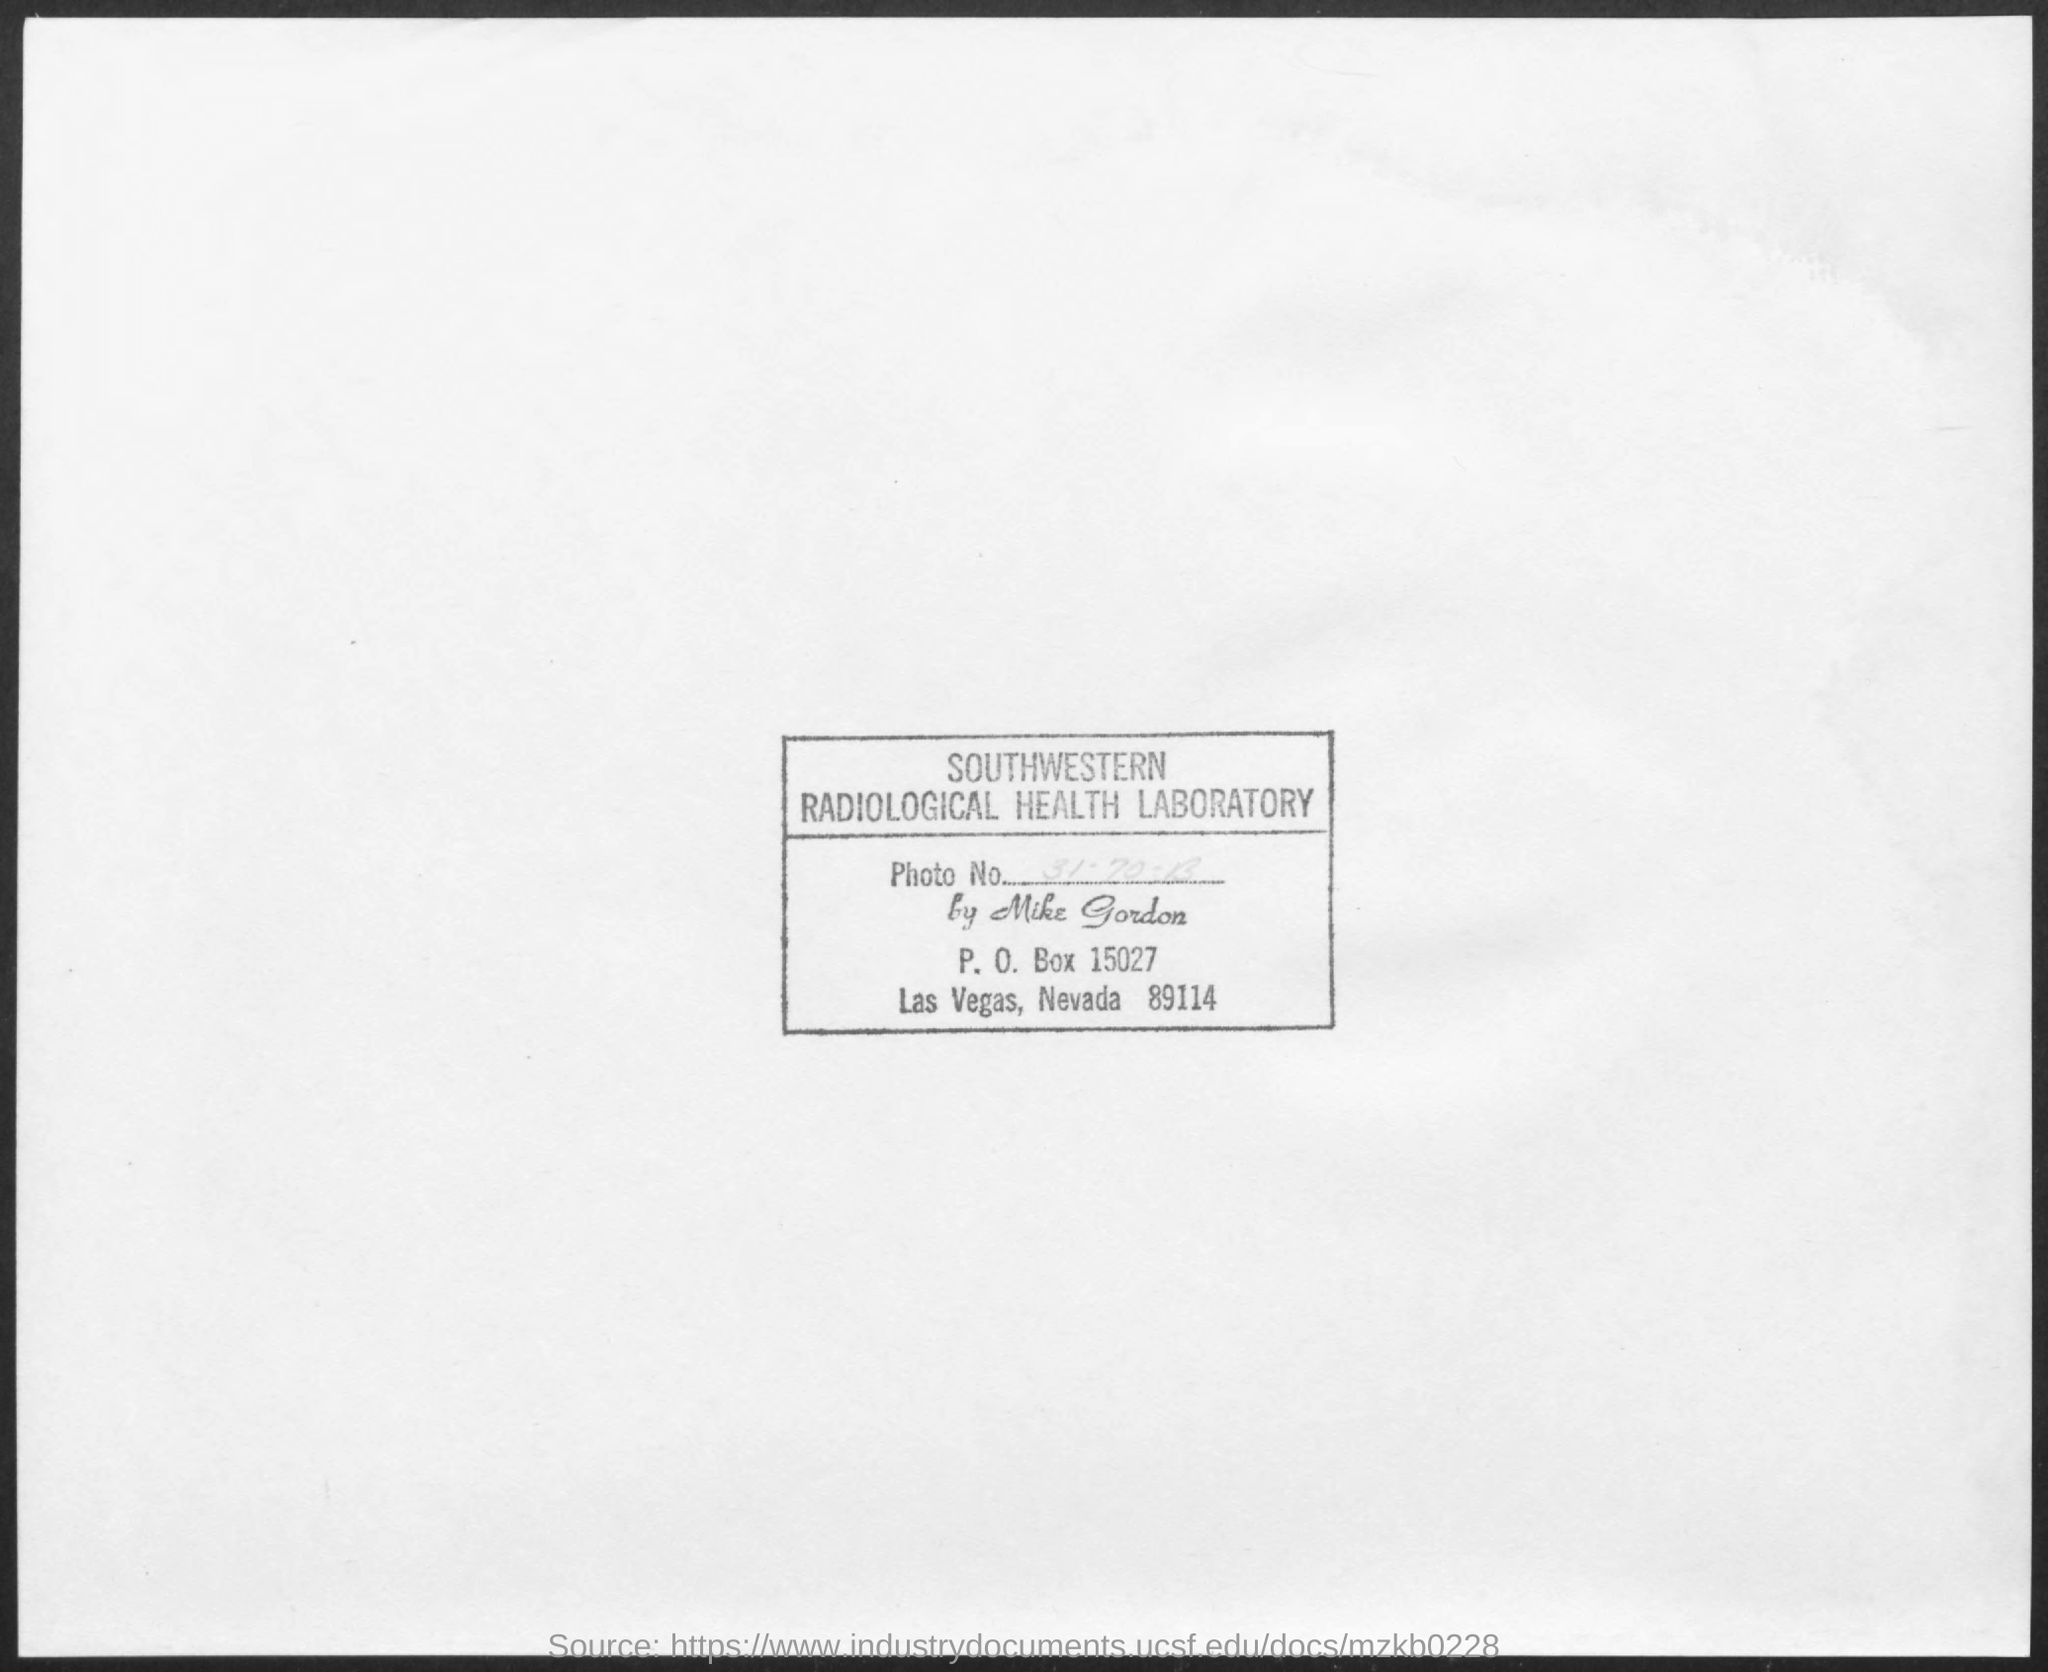Draw attention to some important aspects in this diagram. The P.O. Box is a physical address used for receiving mail and packages that is typically found at a post office or mail facility. Las Vegas, Nevada is the location. 